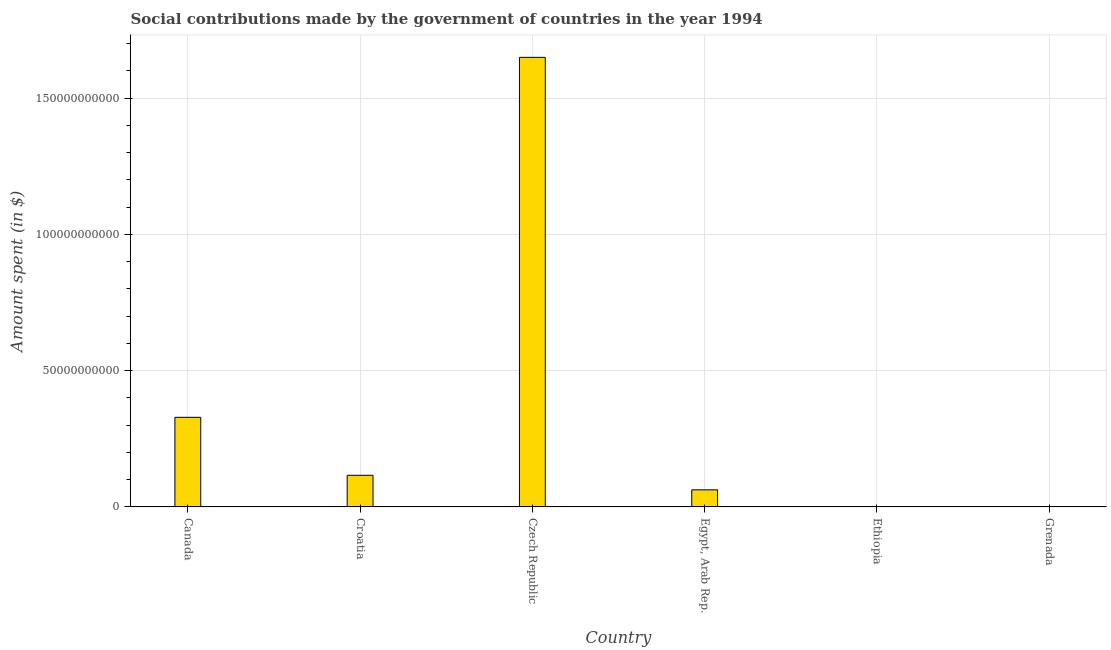Does the graph contain any zero values?
Your response must be concise. No. What is the title of the graph?
Offer a very short reply. Social contributions made by the government of countries in the year 1994. What is the label or title of the X-axis?
Your answer should be compact. Country. What is the label or title of the Y-axis?
Give a very brief answer. Amount spent (in $). Across all countries, what is the maximum amount spent in making social contributions?
Your response must be concise. 1.65e+11. Across all countries, what is the minimum amount spent in making social contributions?
Make the answer very short. 2.00e+04. In which country was the amount spent in making social contributions maximum?
Your answer should be very brief. Czech Republic. In which country was the amount spent in making social contributions minimum?
Give a very brief answer. Grenada. What is the sum of the amount spent in making social contributions?
Ensure brevity in your answer.  2.16e+11. What is the difference between the amount spent in making social contributions in Czech Republic and Ethiopia?
Ensure brevity in your answer.  1.65e+11. What is the average amount spent in making social contributions per country?
Offer a terse response. 3.60e+1. What is the median amount spent in making social contributions?
Make the answer very short. 8.94e+09. In how many countries, is the amount spent in making social contributions greater than 60000000000 $?
Your answer should be compact. 1. What is the ratio of the amount spent in making social contributions in Egypt, Arab Rep. to that in Grenada?
Offer a terse response. 3.14e+05. Is the amount spent in making social contributions in Ethiopia less than that in Grenada?
Keep it short and to the point. No. Is the difference between the amount spent in making social contributions in Canada and Ethiopia greater than the difference between any two countries?
Keep it short and to the point. No. What is the difference between the highest and the second highest amount spent in making social contributions?
Offer a terse response. 1.32e+11. What is the difference between the highest and the lowest amount spent in making social contributions?
Offer a very short reply. 1.65e+11. In how many countries, is the amount spent in making social contributions greater than the average amount spent in making social contributions taken over all countries?
Your response must be concise. 1. How many countries are there in the graph?
Offer a very short reply. 6. Are the values on the major ticks of Y-axis written in scientific E-notation?
Provide a succinct answer. No. What is the Amount spent (in $) of Canada?
Make the answer very short. 3.29e+1. What is the Amount spent (in $) in Croatia?
Your answer should be compact. 1.16e+1. What is the Amount spent (in $) of Czech Republic?
Provide a short and direct response. 1.65e+11. What is the Amount spent (in $) in Egypt, Arab Rep.?
Your answer should be compact. 6.27e+09. What is the Amount spent (in $) in Ethiopia?
Provide a short and direct response. 6.74e+07. What is the Amount spent (in $) in Grenada?
Give a very brief answer. 2.00e+04. What is the difference between the Amount spent (in $) in Canada and Croatia?
Your response must be concise. 2.13e+1. What is the difference between the Amount spent (in $) in Canada and Czech Republic?
Your answer should be compact. -1.32e+11. What is the difference between the Amount spent (in $) in Canada and Egypt, Arab Rep.?
Your response must be concise. 2.66e+1. What is the difference between the Amount spent (in $) in Canada and Ethiopia?
Provide a short and direct response. 3.28e+1. What is the difference between the Amount spent (in $) in Canada and Grenada?
Make the answer very short. 3.29e+1. What is the difference between the Amount spent (in $) in Croatia and Czech Republic?
Offer a very short reply. -1.53e+11. What is the difference between the Amount spent (in $) in Croatia and Egypt, Arab Rep.?
Provide a succinct answer. 5.33e+09. What is the difference between the Amount spent (in $) in Croatia and Ethiopia?
Give a very brief answer. 1.15e+1. What is the difference between the Amount spent (in $) in Croatia and Grenada?
Keep it short and to the point. 1.16e+1. What is the difference between the Amount spent (in $) in Czech Republic and Egypt, Arab Rep.?
Make the answer very short. 1.59e+11. What is the difference between the Amount spent (in $) in Czech Republic and Ethiopia?
Make the answer very short. 1.65e+11. What is the difference between the Amount spent (in $) in Czech Republic and Grenada?
Offer a terse response. 1.65e+11. What is the difference between the Amount spent (in $) in Egypt, Arab Rep. and Ethiopia?
Give a very brief answer. 6.20e+09. What is the difference between the Amount spent (in $) in Egypt, Arab Rep. and Grenada?
Ensure brevity in your answer.  6.27e+09. What is the difference between the Amount spent (in $) in Ethiopia and Grenada?
Provide a short and direct response. 6.74e+07. What is the ratio of the Amount spent (in $) in Canada to that in Croatia?
Your answer should be compact. 2.83. What is the ratio of the Amount spent (in $) in Canada to that in Czech Republic?
Your response must be concise. 0.2. What is the ratio of the Amount spent (in $) in Canada to that in Egypt, Arab Rep.?
Your response must be concise. 5.24. What is the ratio of the Amount spent (in $) in Canada to that in Ethiopia?
Offer a terse response. 487.7. What is the ratio of the Amount spent (in $) in Canada to that in Grenada?
Offer a terse response. 1.64e+06. What is the ratio of the Amount spent (in $) in Croatia to that in Czech Republic?
Offer a very short reply. 0.07. What is the ratio of the Amount spent (in $) in Croatia to that in Egypt, Arab Rep.?
Your answer should be very brief. 1.85. What is the ratio of the Amount spent (in $) in Croatia to that in Ethiopia?
Your response must be concise. 172.18. What is the ratio of the Amount spent (in $) in Croatia to that in Grenada?
Your response must be concise. 5.80e+05. What is the ratio of the Amount spent (in $) in Czech Republic to that in Egypt, Arab Rep.?
Give a very brief answer. 26.29. What is the ratio of the Amount spent (in $) in Czech Republic to that in Ethiopia?
Provide a short and direct response. 2446.77. What is the ratio of the Amount spent (in $) in Czech Republic to that in Grenada?
Your response must be concise. 8.25e+06. What is the ratio of the Amount spent (in $) in Egypt, Arab Rep. to that in Ethiopia?
Offer a very short reply. 93.06. What is the ratio of the Amount spent (in $) in Egypt, Arab Rep. to that in Grenada?
Offer a terse response. 3.14e+05. What is the ratio of the Amount spent (in $) in Ethiopia to that in Grenada?
Offer a terse response. 3370. 